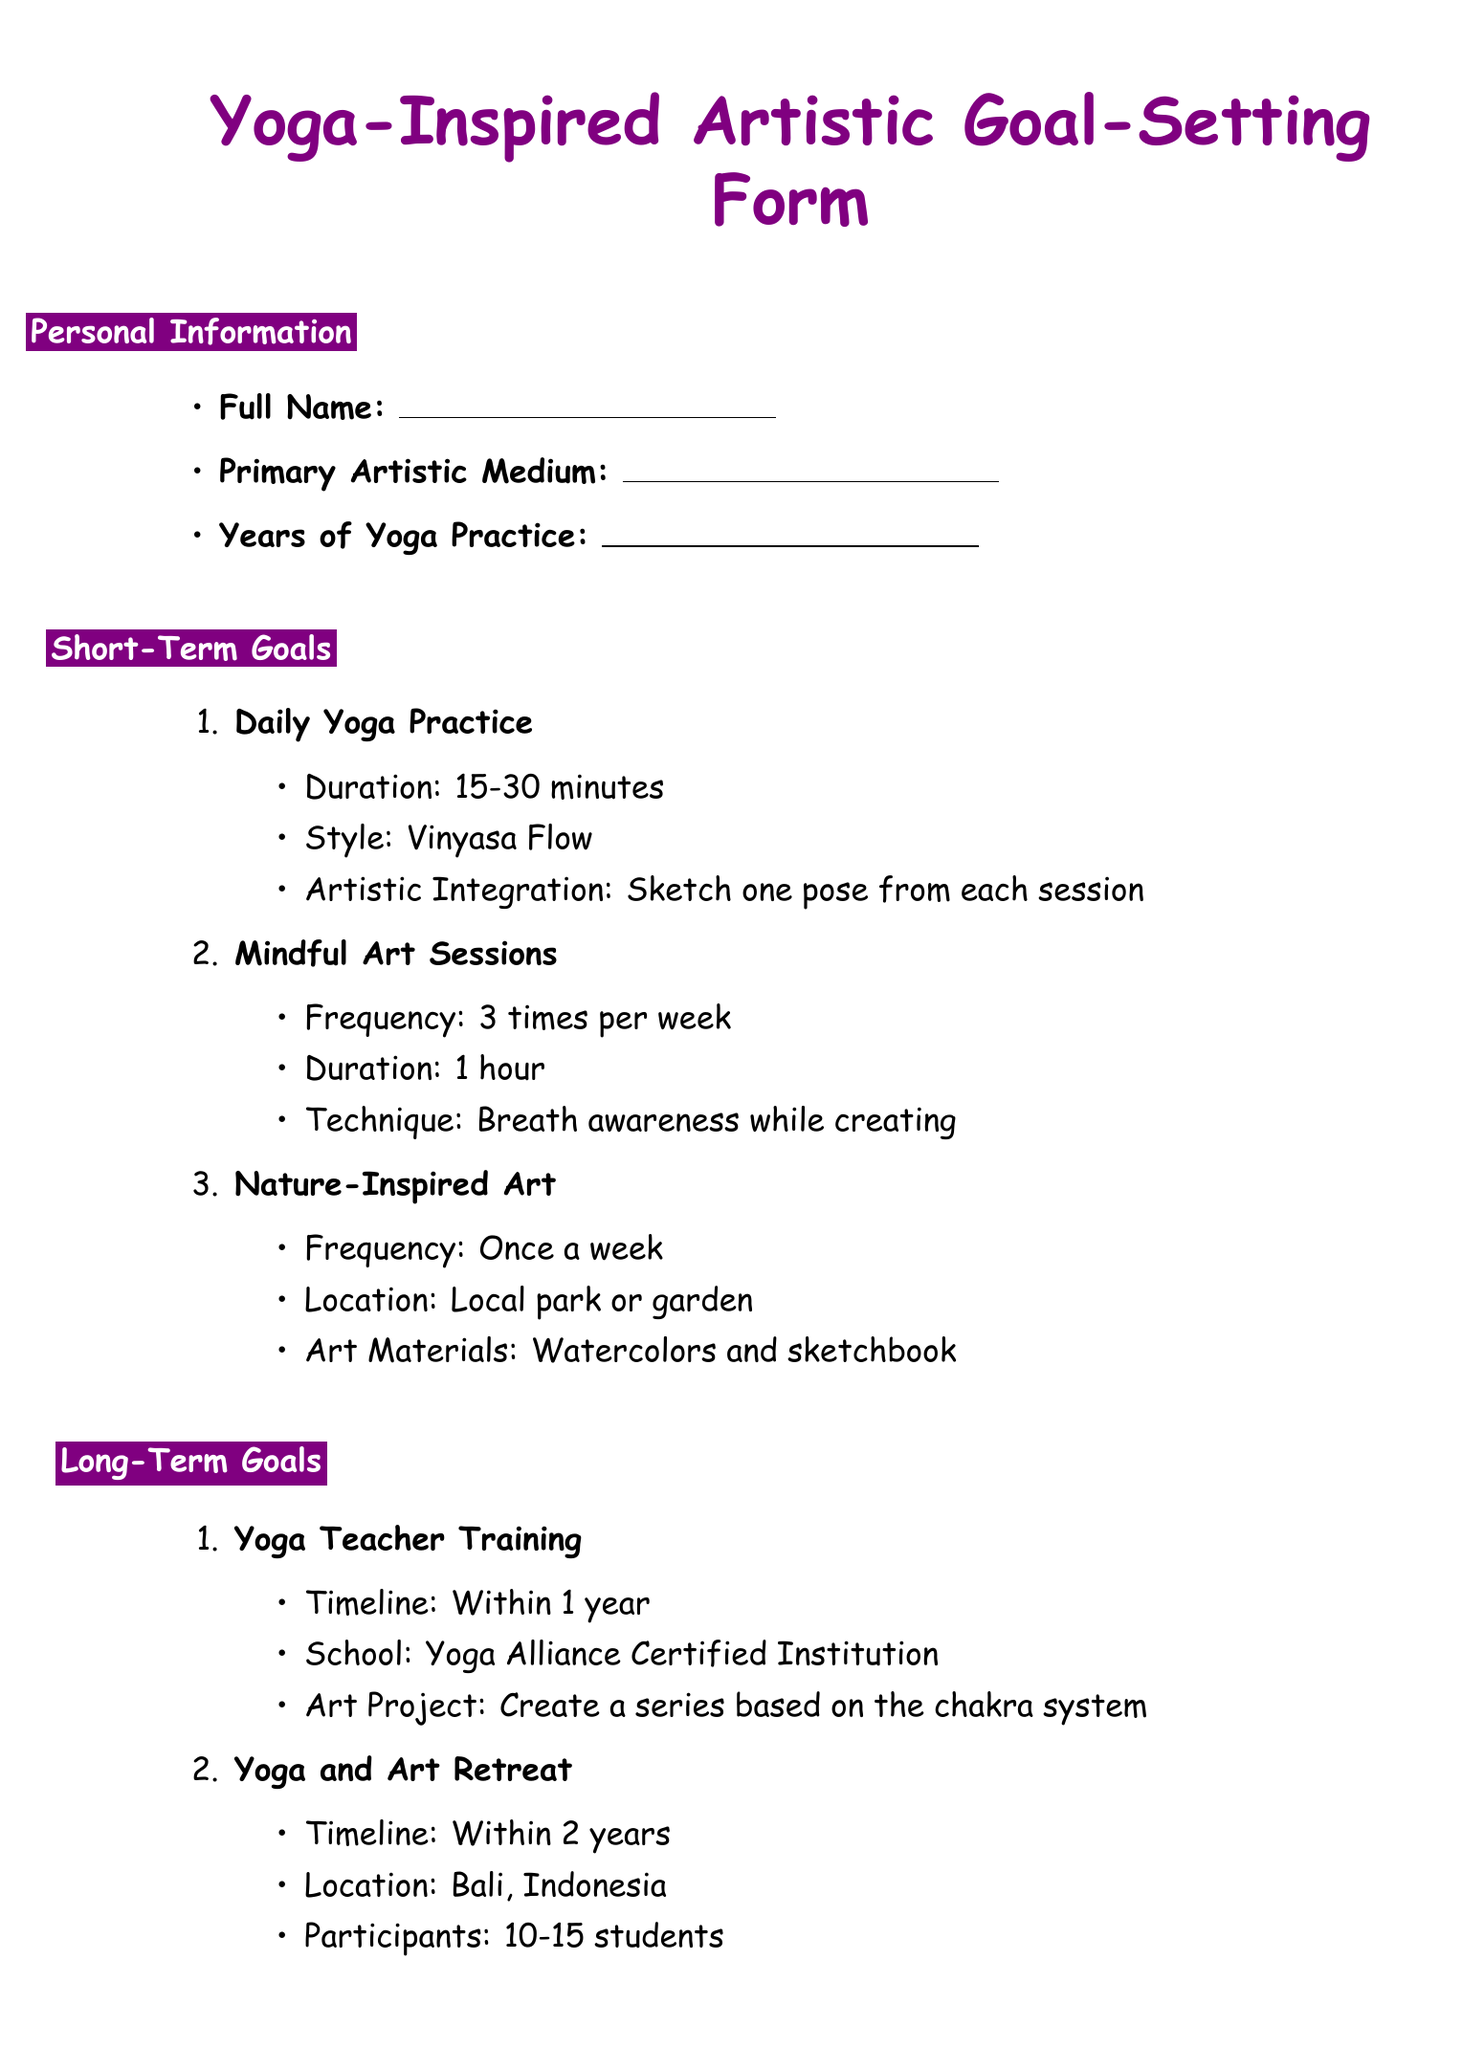What is the title of the form? The title of the form is directly stated at the top of the document.
Answer: Yoga-Inspired Artistic Goal-Setting Form How many years of yoga practice is mentioned in the personal information section? The personal information section contains a field that asks for the number of years of yoga practice.
Answer: Years of Yoga Practice What is the duration of the Daily Yoga Practice short-term goal? The duration for the Daily Yoga Practice is specified in the corresponding item.
Answer: 15-30 minutes What is the frequency of the Mindful Art Sessions? The frequency for Mindful Art Sessions is clearly stated in the short-term goals section.
Answer: 3 times per week What is the timeline for completing Yoga Teacher Training? The timeline for Yoga Teacher Training is indicated in the long-term goals section.
Answer: Within 1 year Which location is mentioned for the Yoga and Art Retreat? The location is specified under the Yoga and Art Retreat long-term goal.
Answer: Bali, Indonesia How many original works are planned for the Yoga-Inspired Art Exhibition? The number of original works is mentioned in the long-term goals section related to the exhibition.
Answer: 15-20 original works Which technique is suggested for the Mindful Art Sessions? The technique for Mindful Art Sessions is provided in the corresponding item.
Answer: Breath awareness while creating What resource type is "The Artist's Way: A Spiritual Path to Higher Creativity"? The type of the resource is explicitly stated in the inspirational resources section.
Answer: Book 